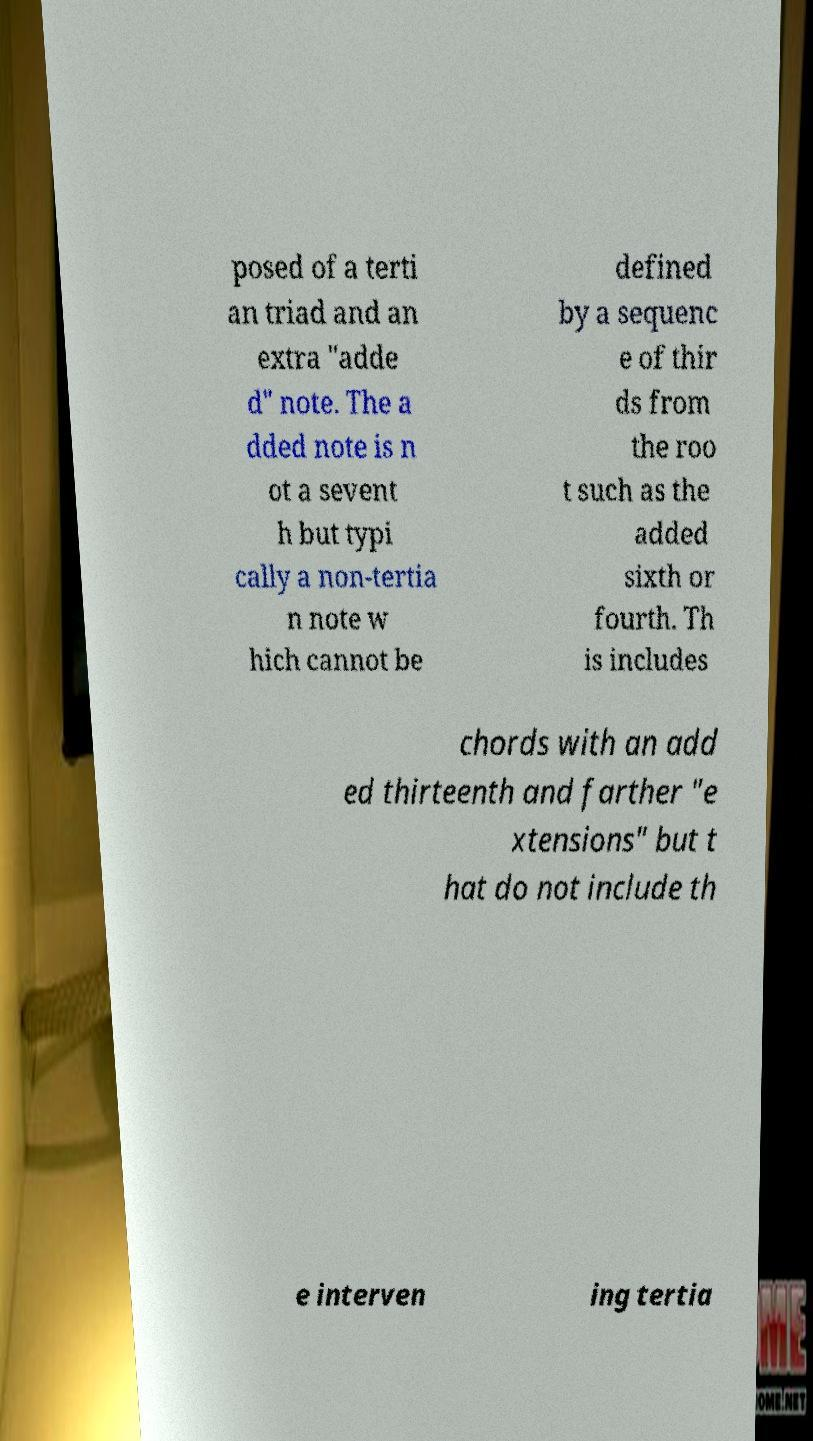Please read and relay the text visible in this image. What does it say? posed of a terti an triad and an extra "adde d" note. The a dded note is n ot a sevent h but typi cally a non-tertia n note w hich cannot be defined by a sequenc e of thir ds from the roo t such as the added sixth or fourth. Th is includes chords with an add ed thirteenth and farther "e xtensions" but t hat do not include th e interven ing tertia 